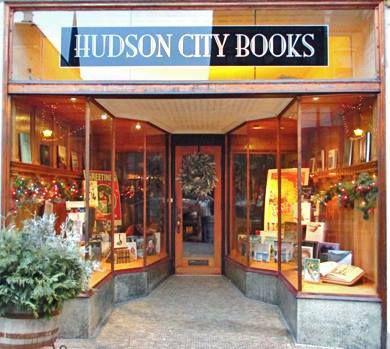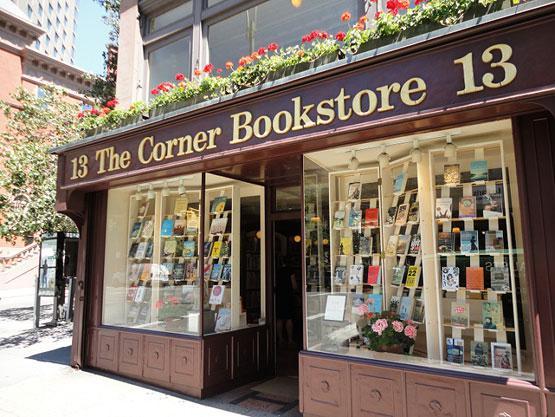The first image is the image on the left, the second image is the image on the right. Analyze the images presented: Is the assertion "Both images show merchandise displayed inside an exterior window." valid? Answer yes or no. Yes. The first image is the image on the left, the second image is the image on the right. Evaluate the accuracy of this statement regarding the images: "Outside storefront views of local bookstores.". Is it true? Answer yes or no. Yes. 